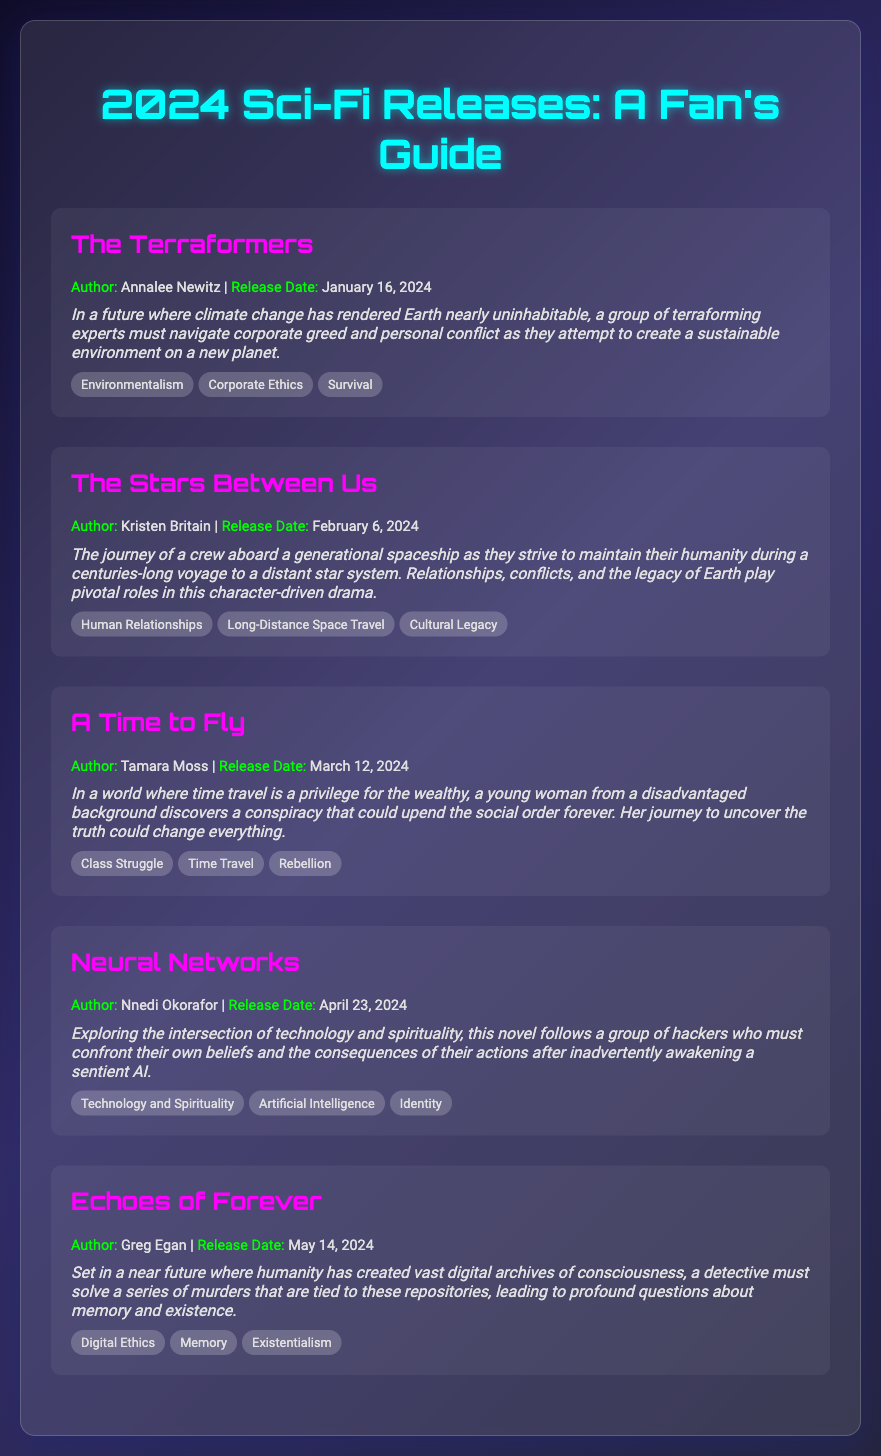What is the title of the book by Annalee Newitz? The title is listed directly under the author's name in the section about her book.
Answer: The Terraformers When is "A Time to Fly" scheduled to be released? The release date for "A Time to Fly" is stated next to the book title and author information.
Answer: March 12, 2024 Who is the author of "Neural Networks"? The author's name is mentioned in the book section along with the release date and synopsis.
Answer: Nnedi Okorafor What theme is associated with "Echoes of Forever"? The themes are listed in a separate section for each book, which highlights significant ideas explored in the story.
Answer: Digital Ethics How many books are listed in the document? The total number of individual book entries can be counted from the sections dedicated to each book in the agenda.
Answer: 5 Which book explores the theme of Class Struggle? The themes are specified under each book, pointing to the relevant entries that categorize the book's focus.
Answer: A Time to Fly What significant event must the crew confront in "The Stars Between Us"? The synopsis provides insight into the main issues the characters deal with throughout the story.
Answer: Their humanity What common theme is found in both "Neural Networks" and "Echoes of Forever"? By comparing the themes listed for each book, we can identify shared concepts.
Answer: Identity 